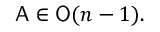<formula> <loc_0><loc_0><loc_500><loc_500>{ A } \in { O } ( n - 1 ) .</formula> 